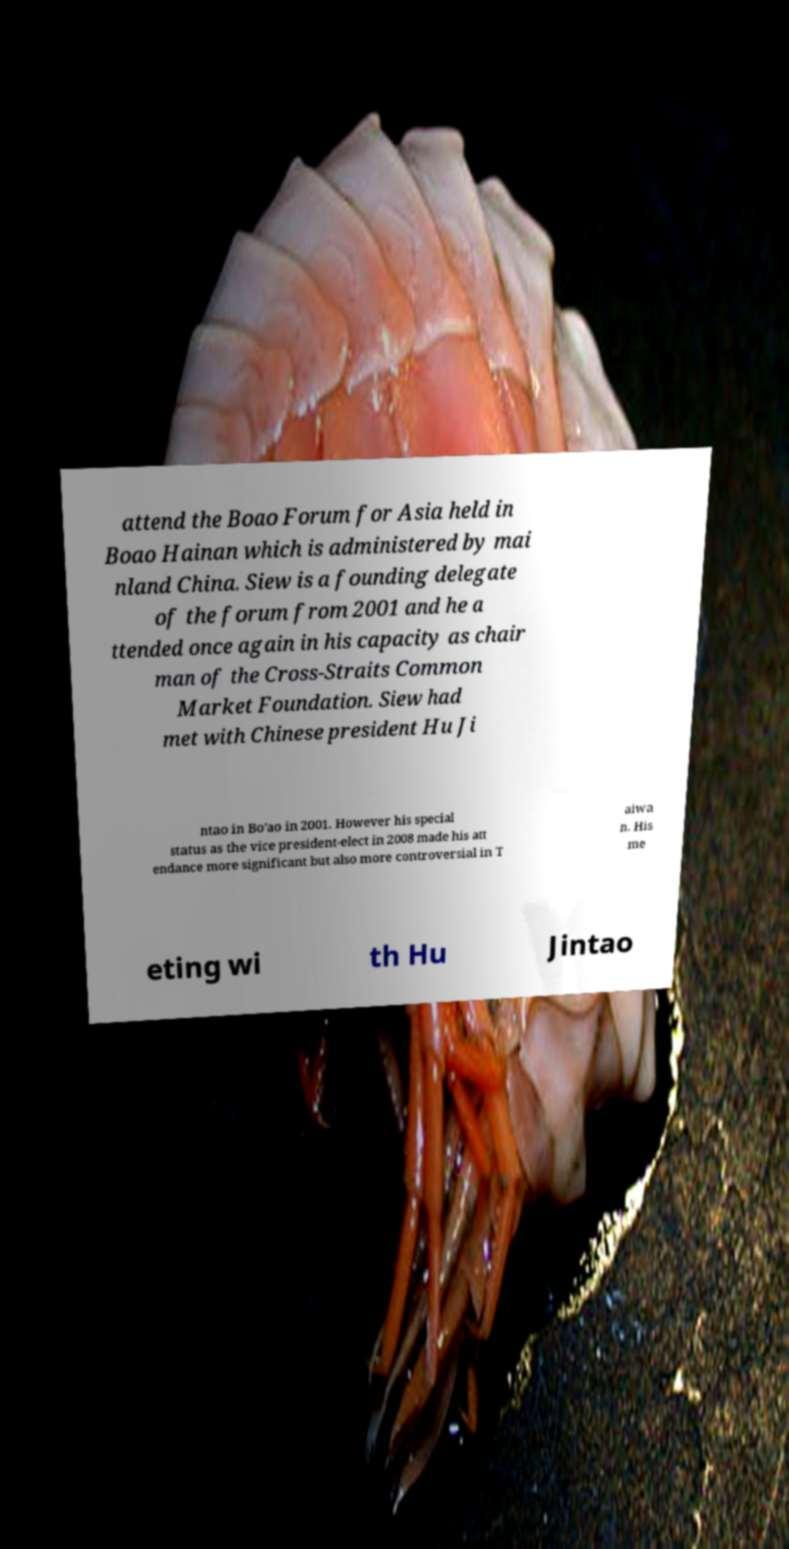Can you accurately transcribe the text from the provided image for me? attend the Boao Forum for Asia held in Boao Hainan which is administered by mai nland China. Siew is a founding delegate of the forum from 2001 and he a ttended once again in his capacity as chair man of the Cross-Straits Common Market Foundation. Siew had met with Chinese president Hu Ji ntao in Bo'ao in 2001. However his special status as the vice president-elect in 2008 made his att endance more significant but also more controversial in T aiwa n. His me eting wi th Hu Jintao 